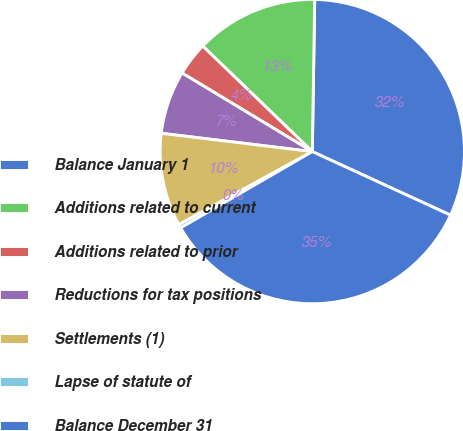Convert chart to OTSL. <chart><loc_0><loc_0><loc_500><loc_500><pie_chart><fcel>Balance January 1<fcel>Additions related to current<fcel>Additions related to prior<fcel>Reductions for tax positions<fcel>Settlements (1)<fcel>Lapse of statute of<fcel>Balance December 31<nl><fcel>31.61%<fcel>13.05%<fcel>3.56%<fcel>6.72%<fcel>9.89%<fcel>0.39%<fcel>34.78%<nl></chart> 